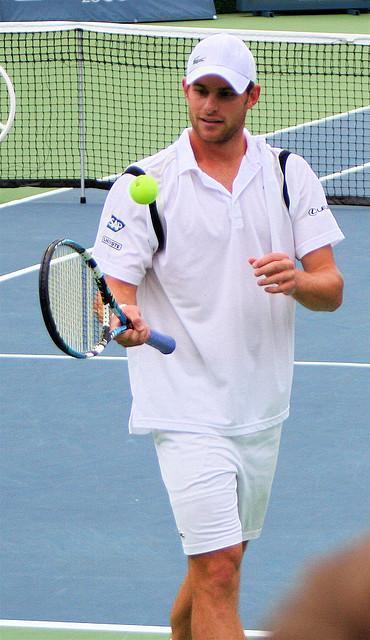How many remotes are seen?
Give a very brief answer. 0. 